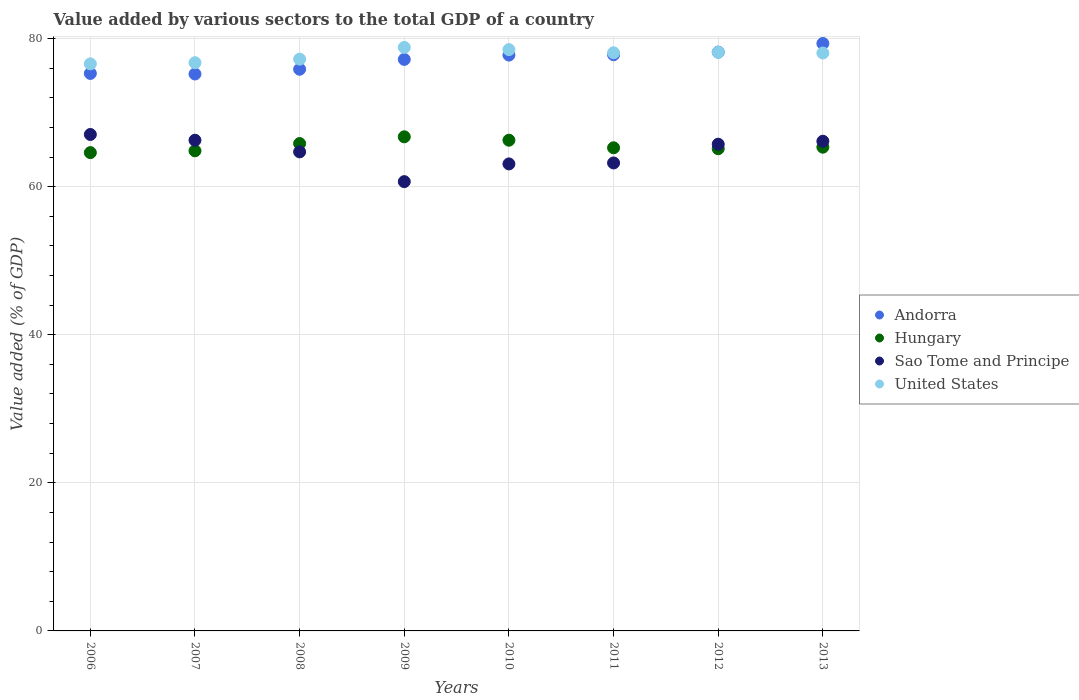How many different coloured dotlines are there?
Provide a succinct answer. 4. What is the value added by various sectors to the total GDP in Sao Tome and Principe in 2010?
Provide a short and direct response. 63.07. Across all years, what is the maximum value added by various sectors to the total GDP in Hungary?
Offer a very short reply. 66.73. Across all years, what is the minimum value added by various sectors to the total GDP in United States?
Make the answer very short. 76.58. In which year was the value added by various sectors to the total GDP in Sao Tome and Principe maximum?
Offer a terse response. 2006. What is the total value added by various sectors to the total GDP in Sao Tome and Principe in the graph?
Ensure brevity in your answer.  516.84. What is the difference between the value added by various sectors to the total GDP in United States in 2007 and that in 2009?
Give a very brief answer. -2.07. What is the difference between the value added by various sectors to the total GDP in Hungary in 2010 and the value added by various sectors to the total GDP in United States in 2007?
Give a very brief answer. -10.47. What is the average value added by various sectors to the total GDP in Hungary per year?
Your response must be concise. 65.5. In the year 2007, what is the difference between the value added by various sectors to the total GDP in Hungary and value added by various sectors to the total GDP in United States?
Provide a short and direct response. -11.9. In how many years, is the value added by various sectors to the total GDP in Sao Tome and Principe greater than 48 %?
Your answer should be compact. 8. What is the ratio of the value added by various sectors to the total GDP in Sao Tome and Principe in 2006 to that in 2010?
Offer a very short reply. 1.06. Is the value added by various sectors to the total GDP in Andorra in 2007 less than that in 2010?
Make the answer very short. Yes. What is the difference between the highest and the second highest value added by various sectors to the total GDP in Andorra?
Provide a succinct answer. 1.16. What is the difference between the highest and the lowest value added by various sectors to the total GDP in Sao Tome and Principe?
Offer a very short reply. 6.37. Is it the case that in every year, the sum of the value added by various sectors to the total GDP in Andorra and value added by various sectors to the total GDP in Sao Tome and Principe  is greater than the value added by various sectors to the total GDP in United States?
Ensure brevity in your answer.  Yes. Does the value added by various sectors to the total GDP in Sao Tome and Principe monotonically increase over the years?
Provide a short and direct response. No. Is the value added by various sectors to the total GDP in Hungary strictly greater than the value added by various sectors to the total GDP in Andorra over the years?
Ensure brevity in your answer.  No. Is the value added by various sectors to the total GDP in Andorra strictly less than the value added by various sectors to the total GDP in Sao Tome and Principe over the years?
Your response must be concise. No. How many dotlines are there?
Your answer should be compact. 4. How many years are there in the graph?
Your answer should be compact. 8. Are the values on the major ticks of Y-axis written in scientific E-notation?
Provide a short and direct response. No. How many legend labels are there?
Ensure brevity in your answer.  4. How are the legend labels stacked?
Keep it short and to the point. Vertical. What is the title of the graph?
Your response must be concise. Value added by various sectors to the total GDP of a country. Does "East Asia (developing only)" appear as one of the legend labels in the graph?
Give a very brief answer. No. What is the label or title of the Y-axis?
Your answer should be compact. Value added (% of GDP). What is the Value added (% of GDP) of Andorra in 2006?
Your answer should be compact. 75.29. What is the Value added (% of GDP) of Hungary in 2006?
Give a very brief answer. 64.6. What is the Value added (% of GDP) in Sao Tome and Principe in 2006?
Provide a succinct answer. 67.05. What is the Value added (% of GDP) in United States in 2006?
Ensure brevity in your answer.  76.58. What is the Value added (% of GDP) in Andorra in 2007?
Make the answer very short. 75.21. What is the Value added (% of GDP) of Hungary in 2007?
Keep it short and to the point. 64.84. What is the Value added (% of GDP) in Sao Tome and Principe in 2007?
Your answer should be compact. 66.27. What is the Value added (% of GDP) in United States in 2007?
Ensure brevity in your answer.  76.74. What is the Value added (% of GDP) in Andorra in 2008?
Make the answer very short. 75.86. What is the Value added (% of GDP) in Hungary in 2008?
Provide a succinct answer. 65.82. What is the Value added (% of GDP) of Sao Tome and Principe in 2008?
Your response must be concise. 64.7. What is the Value added (% of GDP) in United States in 2008?
Provide a succinct answer. 77.22. What is the Value added (% of GDP) of Andorra in 2009?
Make the answer very short. 77.19. What is the Value added (% of GDP) in Hungary in 2009?
Offer a terse response. 66.73. What is the Value added (% of GDP) of Sao Tome and Principe in 2009?
Provide a short and direct response. 60.68. What is the Value added (% of GDP) in United States in 2009?
Give a very brief answer. 78.81. What is the Value added (% of GDP) of Andorra in 2010?
Offer a very short reply. 77.77. What is the Value added (% of GDP) in Hungary in 2010?
Ensure brevity in your answer.  66.27. What is the Value added (% of GDP) of Sao Tome and Principe in 2010?
Offer a terse response. 63.07. What is the Value added (% of GDP) of United States in 2010?
Offer a very short reply. 78.51. What is the Value added (% of GDP) in Andorra in 2011?
Ensure brevity in your answer.  77.82. What is the Value added (% of GDP) in Hungary in 2011?
Ensure brevity in your answer.  65.25. What is the Value added (% of GDP) in Sao Tome and Principe in 2011?
Keep it short and to the point. 63.2. What is the Value added (% of GDP) in United States in 2011?
Keep it short and to the point. 78.08. What is the Value added (% of GDP) in Andorra in 2012?
Offer a very short reply. 78.17. What is the Value added (% of GDP) in Hungary in 2012?
Keep it short and to the point. 65.12. What is the Value added (% of GDP) of Sao Tome and Principe in 2012?
Ensure brevity in your answer.  65.73. What is the Value added (% of GDP) in United States in 2012?
Offer a terse response. 78.15. What is the Value added (% of GDP) of Andorra in 2013?
Offer a terse response. 79.34. What is the Value added (% of GDP) of Hungary in 2013?
Your response must be concise. 65.33. What is the Value added (% of GDP) of Sao Tome and Principe in 2013?
Keep it short and to the point. 66.13. What is the Value added (% of GDP) in United States in 2013?
Offer a terse response. 78.05. Across all years, what is the maximum Value added (% of GDP) in Andorra?
Make the answer very short. 79.34. Across all years, what is the maximum Value added (% of GDP) in Hungary?
Ensure brevity in your answer.  66.73. Across all years, what is the maximum Value added (% of GDP) of Sao Tome and Principe?
Provide a short and direct response. 67.05. Across all years, what is the maximum Value added (% of GDP) of United States?
Provide a short and direct response. 78.81. Across all years, what is the minimum Value added (% of GDP) of Andorra?
Give a very brief answer. 75.21. Across all years, what is the minimum Value added (% of GDP) of Hungary?
Offer a very short reply. 64.6. Across all years, what is the minimum Value added (% of GDP) in Sao Tome and Principe?
Offer a very short reply. 60.68. Across all years, what is the minimum Value added (% of GDP) of United States?
Offer a terse response. 76.58. What is the total Value added (% of GDP) of Andorra in the graph?
Make the answer very short. 616.65. What is the total Value added (% of GDP) in Hungary in the graph?
Ensure brevity in your answer.  523.97. What is the total Value added (% of GDP) in Sao Tome and Principe in the graph?
Keep it short and to the point. 516.84. What is the total Value added (% of GDP) in United States in the graph?
Provide a succinct answer. 622.14. What is the difference between the Value added (% of GDP) in Andorra in 2006 and that in 2007?
Provide a short and direct response. 0.08. What is the difference between the Value added (% of GDP) of Hungary in 2006 and that in 2007?
Provide a succinct answer. -0.24. What is the difference between the Value added (% of GDP) in Sao Tome and Principe in 2006 and that in 2007?
Keep it short and to the point. 0.78. What is the difference between the Value added (% of GDP) of United States in 2006 and that in 2007?
Your response must be concise. -0.16. What is the difference between the Value added (% of GDP) of Andorra in 2006 and that in 2008?
Your answer should be compact. -0.57. What is the difference between the Value added (% of GDP) in Hungary in 2006 and that in 2008?
Provide a short and direct response. -1.23. What is the difference between the Value added (% of GDP) in Sao Tome and Principe in 2006 and that in 2008?
Keep it short and to the point. 2.35. What is the difference between the Value added (% of GDP) in United States in 2006 and that in 2008?
Keep it short and to the point. -0.64. What is the difference between the Value added (% of GDP) of Andorra in 2006 and that in 2009?
Your answer should be compact. -1.9. What is the difference between the Value added (% of GDP) in Hungary in 2006 and that in 2009?
Make the answer very short. -2.14. What is the difference between the Value added (% of GDP) in Sao Tome and Principe in 2006 and that in 2009?
Your answer should be compact. 6.37. What is the difference between the Value added (% of GDP) in United States in 2006 and that in 2009?
Your response must be concise. -2.23. What is the difference between the Value added (% of GDP) in Andorra in 2006 and that in 2010?
Your response must be concise. -2.48. What is the difference between the Value added (% of GDP) in Hungary in 2006 and that in 2010?
Make the answer very short. -1.68. What is the difference between the Value added (% of GDP) of Sao Tome and Principe in 2006 and that in 2010?
Your answer should be compact. 3.98. What is the difference between the Value added (% of GDP) in United States in 2006 and that in 2010?
Your answer should be compact. -1.93. What is the difference between the Value added (% of GDP) in Andorra in 2006 and that in 2011?
Keep it short and to the point. -2.53. What is the difference between the Value added (% of GDP) in Hungary in 2006 and that in 2011?
Offer a terse response. -0.65. What is the difference between the Value added (% of GDP) of Sao Tome and Principe in 2006 and that in 2011?
Provide a short and direct response. 3.85. What is the difference between the Value added (% of GDP) in United States in 2006 and that in 2011?
Make the answer very short. -1.5. What is the difference between the Value added (% of GDP) in Andorra in 2006 and that in 2012?
Provide a succinct answer. -2.88. What is the difference between the Value added (% of GDP) in Hungary in 2006 and that in 2012?
Provide a succinct answer. -0.53. What is the difference between the Value added (% of GDP) of Sao Tome and Principe in 2006 and that in 2012?
Your answer should be very brief. 1.31. What is the difference between the Value added (% of GDP) in United States in 2006 and that in 2012?
Your answer should be very brief. -1.57. What is the difference between the Value added (% of GDP) in Andorra in 2006 and that in 2013?
Offer a very short reply. -4.05. What is the difference between the Value added (% of GDP) of Hungary in 2006 and that in 2013?
Your answer should be compact. -0.74. What is the difference between the Value added (% of GDP) of Sao Tome and Principe in 2006 and that in 2013?
Make the answer very short. 0.91. What is the difference between the Value added (% of GDP) in United States in 2006 and that in 2013?
Offer a terse response. -1.47. What is the difference between the Value added (% of GDP) in Andorra in 2007 and that in 2008?
Ensure brevity in your answer.  -0.64. What is the difference between the Value added (% of GDP) of Hungary in 2007 and that in 2008?
Your answer should be very brief. -0.98. What is the difference between the Value added (% of GDP) of Sao Tome and Principe in 2007 and that in 2008?
Provide a succinct answer. 1.57. What is the difference between the Value added (% of GDP) in United States in 2007 and that in 2008?
Ensure brevity in your answer.  -0.48. What is the difference between the Value added (% of GDP) of Andorra in 2007 and that in 2009?
Your answer should be compact. -1.97. What is the difference between the Value added (% of GDP) of Hungary in 2007 and that in 2009?
Offer a terse response. -1.89. What is the difference between the Value added (% of GDP) in Sao Tome and Principe in 2007 and that in 2009?
Offer a very short reply. 5.59. What is the difference between the Value added (% of GDP) of United States in 2007 and that in 2009?
Provide a short and direct response. -2.07. What is the difference between the Value added (% of GDP) of Andorra in 2007 and that in 2010?
Offer a terse response. -2.56. What is the difference between the Value added (% of GDP) of Hungary in 2007 and that in 2010?
Provide a short and direct response. -1.43. What is the difference between the Value added (% of GDP) in Sao Tome and Principe in 2007 and that in 2010?
Provide a succinct answer. 3.2. What is the difference between the Value added (% of GDP) in United States in 2007 and that in 2010?
Your answer should be very brief. -1.77. What is the difference between the Value added (% of GDP) in Andorra in 2007 and that in 2011?
Offer a very short reply. -2.6. What is the difference between the Value added (% of GDP) in Hungary in 2007 and that in 2011?
Your answer should be very brief. -0.41. What is the difference between the Value added (% of GDP) in Sao Tome and Principe in 2007 and that in 2011?
Your answer should be compact. 3.07. What is the difference between the Value added (% of GDP) of United States in 2007 and that in 2011?
Give a very brief answer. -1.34. What is the difference between the Value added (% of GDP) of Andorra in 2007 and that in 2012?
Offer a very short reply. -2.96. What is the difference between the Value added (% of GDP) in Hungary in 2007 and that in 2012?
Your answer should be very brief. -0.28. What is the difference between the Value added (% of GDP) in Sao Tome and Principe in 2007 and that in 2012?
Your answer should be compact. 0.54. What is the difference between the Value added (% of GDP) in United States in 2007 and that in 2012?
Offer a very short reply. -1.41. What is the difference between the Value added (% of GDP) of Andorra in 2007 and that in 2013?
Provide a succinct answer. -4.12. What is the difference between the Value added (% of GDP) of Hungary in 2007 and that in 2013?
Keep it short and to the point. -0.49. What is the difference between the Value added (% of GDP) in Sao Tome and Principe in 2007 and that in 2013?
Give a very brief answer. 0.14. What is the difference between the Value added (% of GDP) in United States in 2007 and that in 2013?
Provide a short and direct response. -1.31. What is the difference between the Value added (% of GDP) of Andorra in 2008 and that in 2009?
Ensure brevity in your answer.  -1.33. What is the difference between the Value added (% of GDP) of Hungary in 2008 and that in 2009?
Give a very brief answer. -0.91. What is the difference between the Value added (% of GDP) in Sao Tome and Principe in 2008 and that in 2009?
Provide a succinct answer. 4.02. What is the difference between the Value added (% of GDP) in United States in 2008 and that in 2009?
Provide a short and direct response. -1.59. What is the difference between the Value added (% of GDP) of Andorra in 2008 and that in 2010?
Make the answer very short. -1.91. What is the difference between the Value added (% of GDP) in Hungary in 2008 and that in 2010?
Keep it short and to the point. -0.45. What is the difference between the Value added (% of GDP) in Sao Tome and Principe in 2008 and that in 2010?
Keep it short and to the point. 1.63. What is the difference between the Value added (% of GDP) of United States in 2008 and that in 2010?
Your response must be concise. -1.28. What is the difference between the Value added (% of GDP) of Andorra in 2008 and that in 2011?
Provide a short and direct response. -1.96. What is the difference between the Value added (% of GDP) in Hungary in 2008 and that in 2011?
Ensure brevity in your answer.  0.57. What is the difference between the Value added (% of GDP) of Sao Tome and Principe in 2008 and that in 2011?
Make the answer very short. 1.5. What is the difference between the Value added (% of GDP) of United States in 2008 and that in 2011?
Give a very brief answer. -0.86. What is the difference between the Value added (% of GDP) in Andorra in 2008 and that in 2012?
Give a very brief answer. -2.32. What is the difference between the Value added (% of GDP) in Sao Tome and Principe in 2008 and that in 2012?
Offer a very short reply. -1.04. What is the difference between the Value added (% of GDP) of United States in 2008 and that in 2012?
Your answer should be compact. -0.92. What is the difference between the Value added (% of GDP) in Andorra in 2008 and that in 2013?
Offer a terse response. -3.48. What is the difference between the Value added (% of GDP) in Hungary in 2008 and that in 2013?
Keep it short and to the point. 0.49. What is the difference between the Value added (% of GDP) in Sao Tome and Principe in 2008 and that in 2013?
Provide a short and direct response. -1.44. What is the difference between the Value added (% of GDP) in United States in 2008 and that in 2013?
Your response must be concise. -0.83. What is the difference between the Value added (% of GDP) of Andorra in 2009 and that in 2010?
Make the answer very short. -0.58. What is the difference between the Value added (% of GDP) in Hungary in 2009 and that in 2010?
Provide a succinct answer. 0.46. What is the difference between the Value added (% of GDP) of Sao Tome and Principe in 2009 and that in 2010?
Your answer should be compact. -2.39. What is the difference between the Value added (% of GDP) of United States in 2009 and that in 2010?
Your answer should be very brief. 0.3. What is the difference between the Value added (% of GDP) of Andorra in 2009 and that in 2011?
Give a very brief answer. -0.63. What is the difference between the Value added (% of GDP) in Hungary in 2009 and that in 2011?
Your answer should be very brief. 1.48. What is the difference between the Value added (% of GDP) in Sao Tome and Principe in 2009 and that in 2011?
Make the answer very short. -2.52. What is the difference between the Value added (% of GDP) of United States in 2009 and that in 2011?
Give a very brief answer. 0.73. What is the difference between the Value added (% of GDP) in Andorra in 2009 and that in 2012?
Give a very brief answer. -0.99. What is the difference between the Value added (% of GDP) in Hungary in 2009 and that in 2012?
Provide a short and direct response. 1.61. What is the difference between the Value added (% of GDP) of Sao Tome and Principe in 2009 and that in 2012?
Your response must be concise. -5.06. What is the difference between the Value added (% of GDP) in United States in 2009 and that in 2012?
Provide a succinct answer. 0.66. What is the difference between the Value added (% of GDP) in Andorra in 2009 and that in 2013?
Your answer should be very brief. -2.15. What is the difference between the Value added (% of GDP) in Hungary in 2009 and that in 2013?
Your answer should be very brief. 1.4. What is the difference between the Value added (% of GDP) in Sao Tome and Principe in 2009 and that in 2013?
Offer a terse response. -5.46. What is the difference between the Value added (% of GDP) in United States in 2009 and that in 2013?
Ensure brevity in your answer.  0.76. What is the difference between the Value added (% of GDP) of Andorra in 2010 and that in 2011?
Ensure brevity in your answer.  -0.05. What is the difference between the Value added (% of GDP) of Hungary in 2010 and that in 2011?
Offer a very short reply. 1.02. What is the difference between the Value added (% of GDP) of Sao Tome and Principe in 2010 and that in 2011?
Your answer should be compact. -0.13. What is the difference between the Value added (% of GDP) in United States in 2010 and that in 2011?
Offer a terse response. 0.43. What is the difference between the Value added (% of GDP) in Andorra in 2010 and that in 2012?
Keep it short and to the point. -0.4. What is the difference between the Value added (% of GDP) in Hungary in 2010 and that in 2012?
Your answer should be very brief. 1.15. What is the difference between the Value added (% of GDP) of Sao Tome and Principe in 2010 and that in 2012?
Give a very brief answer. -2.66. What is the difference between the Value added (% of GDP) in United States in 2010 and that in 2012?
Your answer should be compact. 0.36. What is the difference between the Value added (% of GDP) in Andorra in 2010 and that in 2013?
Your response must be concise. -1.57. What is the difference between the Value added (% of GDP) of Hungary in 2010 and that in 2013?
Give a very brief answer. 0.94. What is the difference between the Value added (% of GDP) in Sao Tome and Principe in 2010 and that in 2013?
Make the answer very short. -3.06. What is the difference between the Value added (% of GDP) in United States in 2010 and that in 2013?
Give a very brief answer. 0.46. What is the difference between the Value added (% of GDP) of Andorra in 2011 and that in 2012?
Offer a terse response. -0.35. What is the difference between the Value added (% of GDP) of Hungary in 2011 and that in 2012?
Make the answer very short. 0.13. What is the difference between the Value added (% of GDP) in Sao Tome and Principe in 2011 and that in 2012?
Keep it short and to the point. -2.53. What is the difference between the Value added (% of GDP) of United States in 2011 and that in 2012?
Your response must be concise. -0.07. What is the difference between the Value added (% of GDP) of Andorra in 2011 and that in 2013?
Offer a very short reply. -1.52. What is the difference between the Value added (% of GDP) in Hungary in 2011 and that in 2013?
Provide a succinct answer. -0.08. What is the difference between the Value added (% of GDP) in Sao Tome and Principe in 2011 and that in 2013?
Offer a very short reply. -2.93. What is the difference between the Value added (% of GDP) in United States in 2011 and that in 2013?
Your answer should be compact. 0.03. What is the difference between the Value added (% of GDP) of Andorra in 2012 and that in 2013?
Ensure brevity in your answer.  -1.16. What is the difference between the Value added (% of GDP) of Hungary in 2012 and that in 2013?
Offer a terse response. -0.21. What is the difference between the Value added (% of GDP) of Sao Tome and Principe in 2012 and that in 2013?
Offer a terse response. -0.4. What is the difference between the Value added (% of GDP) of United States in 2012 and that in 2013?
Your response must be concise. 0.09. What is the difference between the Value added (% of GDP) of Andorra in 2006 and the Value added (% of GDP) of Hungary in 2007?
Your answer should be compact. 10.45. What is the difference between the Value added (% of GDP) of Andorra in 2006 and the Value added (% of GDP) of Sao Tome and Principe in 2007?
Keep it short and to the point. 9.02. What is the difference between the Value added (% of GDP) of Andorra in 2006 and the Value added (% of GDP) of United States in 2007?
Your response must be concise. -1.45. What is the difference between the Value added (% of GDP) of Hungary in 2006 and the Value added (% of GDP) of Sao Tome and Principe in 2007?
Your response must be concise. -1.67. What is the difference between the Value added (% of GDP) of Hungary in 2006 and the Value added (% of GDP) of United States in 2007?
Your answer should be compact. -12.14. What is the difference between the Value added (% of GDP) of Sao Tome and Principe in 2006 and the Value added (% of GDP) of United States in 2007?
Offer a terse response. -9.69. What is the difference between the Value added (% of GDP) of Andorra in 2006 and the Value added (% of GDP) of Hungary in 2008?
Give a very brief answer. 9.47. What is the difference between the Value added (% of GDP) in Andorra in 2006 and the Value added (% of GDP) in Sao Tome and Principe in 2008?
Make the answer very short. 10.59. What is the difference between the Value added (% of GDP) in Andorra in 2006 and the Value added (% of GDP) in United States in 2008?
Your answer should be very brief. -1.93. What is the difference between the Value added (% of GDP) of Hungary in 2006 and the Value added (% of GDP) of Sao Tome and Principe in 2008?
Offer a very short reply. -0.1. What is the difference between the Value added (% of GDP) in Hungary in 2006 and the Value added (% of GDP) in United States in 2008?
Your response must be concise. -12.63. What is the difference between the Value added (% of GDP) in Sao Tome and Principe in 2006 and the Value added (% of GDP) in United States in 2008?
Make the answer very short. -10.17. What is the difference between the Value added (% of GDP) of Andorra in 2006 and the Value added (% of GDP) of Hungary in 2009?
Your response must be concise. 8.56. What is the difference between the Value added (% of GDP) of Andorra in 2006 and the Value added (% of GDP) of Sao Tome and Principe in 2009?
Ensure brevity in your answer.  14.61. What is the difference between the Value added (% of GDP) of Andorra in 2006 and the Value added (% of GDP) of United States in 2009?
Provide a short and direct response. -3.52. What is the difference between the Value added (% of GDP) of Hungary in 2006 and the Value added (% of GDP) of Sao Tome and Principe in 2009?
Give a very brief answer. 3.92. What is the difference between the Value added (% of GDP) in Hungary in 2006 and the Value added (% of GDP) in United States in 2009?
Your response must be concise. -14.21. What is the difference between the Value added (% of GDP) of Sao Tome and Principe in 2006 and the Value added (% of GDP) of United States in 2009?
Give a very brief answer. -11.76. What is the difference between the Value added (% of GDP) in Andorra in 2006 and the Value added (% of GDP) in Hungary in 2010?
Make the answer very short. 9.02. What is the difference between the Value added (% of GDP) of Andorra in 2006 and the Value added (% of GDP) of Sao Tome and Principe in 2010?
Offer a terse response. 12.22. What is the difference between the Value added (% of GDP) in Andorra in 2006 and the Value added (% of GDP) in United States in 2010?
Ensure brevity in your answer.  -3.22. What is the difference between the Value added (% of GDP) of Hungary in 2006 and the Value added (% of GDP) of Sao Tome and Principe in 2010?
Your answer should be very brief. 1.52. What is the difference between the Value added (% of GDP) of Hungary in 2006 and the Value added (% of GDP) of United States in 2010?
Give a very brief answer. -13.91. What is the difference between the Value added (% of GDP) in Sao Tome and Principe in 2006 and the Value added (% of GDP) in United States in 2010?
Offer a terse response. -11.46. What is the difference between the Value added (% of GDP) of Andorra in 2006 and the Value added (% of GDP) of Hungary in 2011?
Offer a very short reply. 10.04. What is the difference between the Value added (% of GDP) in Andorra in 2006 and the Value added (% of GDP) in Sao Tome and Principe in 2011?
Provide a short and direct response. 12.09. What is the difference between the Value added (% of GDP) in Andorra in 2006 and the Value added (% of GDP) in United States in 2011?
Keep it short and to the point. -2.79. What is the difference between the Value added (% of GDP) in Hungary in 2006 and the Value added (% of GDP) in Sao Tome and Principe in 2011?
Make the answer very short. 1.39. What is the difference between the Value added (% of GDP) in Hungary in 2006 and the Value added (% of GDP) in United States in 2011?
Provide a succinct answer. -13.48. What is the difference between the Value added (% of GDP) in Sao Tome and Principe in 2006 and the Value added (% of GDP) in United States in 2011?
Offer a terse response. -11.03. What is the difference between the Value added (% of GDP) of Andorra in 2006 and the Value added (% of GDP) of Hungary in 2012?
Provide a short and direct response. 10.17. What is the difference between the Value added (% of GDP) in Andorra in 2006 and the Value added (% of GDP) in Sao Tome and Principe in 2012?
Provide a short and direct response. 9.56. What is the difference between the Value added (% of GDP) in Andorra in 2006 and the Value added (% of GDP) in United States in 2012?
Ensure brevity in your answer.  -2.86. What is the difference between the Value added (% of GDP) of Hungary in 2006 and the Value added (% of GDP) of Sao Tome and Principe in 2012?
Keep it short and to the point. -1.14. What is the difference between the Value added (% of GDP) of Hungary in 2006 and the Value added (% of GDP) of United States in 2012?
Ensure brevity in your answer.  -13.55. What is the difference between the Value added (% of GDP) of Sao Tome and Principe in 2006 and the Value added (% of GDP) of United States in 2012?
Give a very brief answer. -11.1. What is the difference between the Value added (% of GDP) in Andorra in 2006 and the Value added (% of GDP) in Hungary in 2013?
Your answer should be very brief. 9.96. What is the difference between the Value added (% of GDP) in Andorra in 2006 and the Value added (% of GDP) in Sao Tome and Principe in 2013?
Provide a succinct answer. 9.16. What is the difference between the Value added (% of GDP) of Andorra in 2006 and the Value added (% of GDP) of United States in 2013?
Give a very brief answer. -2.76. What is the difference between the Value added (% of GDP) in Hungary in 2006 and the Value added (% of GDP) in Sao Tome and Principe in 2013?
Offer a terse response. -1.54. What is the difference between the Value added (% of GDP) in Hungary in 2006 and the Value added (% of GDP) in United States in 2013?
Your answer should be compact. -13.46. What is the difference between the Value added (% of GDP) of Sao Tome and Principe in 2006 and the Value added (% of GDP) of United States in 2013?
Offer a very short reply. -11. What is the difference between the Value added (% of GDP) of Andorra in 2007 and the Value added (% of GDP) of Hungary in 2008?
Provide a succinct answer. 9.39. What is the difference between the Value added (% of GDP) of Andorra in 2007 and the Value added (% of GDP) of Sao Tome and Principe in 2008?
Your answer should be compact. 10.52. What is the difference between the Value added (% of GDP) of Andorra in 2007 and the Value added (% of GDP) of United States in 2008?
Give a very brief answer. -2.01. What is the difference between the Value added (% of GDP) of Hungary in 2007 and the Value added (% of GDP) of Sao Tome and Principe in 2008?
Your response must be concise. 0.14. What is the difference between the Value added (% of GDP) of Hungary in 2007 and the Value added (% of GDP) of United States in 2008?
Your answer should be very brief. -12.38. What is the difference between the Value added (% of GDP) of Sao Tome and Principe in 2007 and the Value added (% of GDP) of United States in 2008?
Provide a succinct answer. -10.95. What is the difference between the Value added (% of GDP) of Andorra in 2007 and the Value added (% of GDP) of Hungary in 2009?
Ensure brevity in your answer.  8.48. What is the difference between the Value added (% of GDP) of Andorra in 2007 and the Value added (% of GDP) of Sao Tome and Principe in 2009?
Provide a succinct answer. 14.54. What is the difference between the Value added (% of GDP) in Andorra in 2007 and the Value added (% of GDP) in United States in 2009?
Your answer should be very brief. -3.59. What is the difference between the Value added (% of GDP) in Hungary in 2007 and the Value added (% of GDP) in Sao Tome and Principe in 2009?
Make the answer very short. 4.16. What is the difference between the Value added (% of GDP) in Hungary in 2007 and the Value added (% of GDP) in United States in 2009?
Keep it short and to the point. -13.97. What is the difference between the Value added (% of GDP) of Sao Tome and Principe in 2007 and the Value added (% of GDP) of United States in 2009?
Offer a terse response. -12.54. What is the difference between the Value added (% of GDP) in Andorra in 2007 and the Value added (% of GDP) in Hungary in 2010?
Keep it short and to the point. 8.94. What is the difference between the Value added (% of GDP) of Andorra in 2007 and the Value added (% of GDP) of Sao Tome and Principe in 2010?
Your answer should be very brief. 12.14. What is the difference between the Value added (% of GDP) of Andorra in 2007 and the Value added (% of GDP) of United States in 2010?
Keep it short and to the point. -3.29. What is the difference between the Value added (% of GDP) in Hungary in 2007 and the Value added (% of GDP) in Sao Tome and Principe in 2010?
Offer a terse response. 1.77. What is the difference between the Value added (% of GDP) in Hungary in 2007 and the Value added (% of GDP) in United States in 2010?
Provide a short and direct response. -13.67. What is the difference between the Value added (% of GDP) of Sao Tome and Principe in 2007 and the Value added (% of GDP) of United States in 2010?
Your answer should be very brief. -12.24. What is the difference between the Value added (% of GDP) of Andorra in 2007 and the Value added (% of GDP) of Hungary in 2011?
Keep it short and to the point. 9.96. What is the difference between the Value added (% of GDP) of Andorra in 2007 and the Value added (% of GDP) of Sao Tome and Principe in 2011?
Offer a very short reply. 12.01. What is the difference between the Value added (% of GDP) in Andorra in 2007 and the Value added (% of GDP) in United States in 2011?
Ensure brevity in your answer.  -2.87. What is the difference between the Value added (% of GDP) in Hungary in 2007 and the Value added (% of GDP) in Sao Tome and Principe in 2011?
Your answer should be very brief. 1.64. What is the difference between the Value added (% of GDP) of Hungary in 2007 and the Value added (% of GDP) of United States in 2011?
Make the answer very short. -13.24. What is the difference between the Value added (% of GDP) of Sao Tome and Principe in 2007 and the Value added (% of GDP) of United States in 2011?
Your answer should be compact. -11.81. What is the difference between the Value added (% of GDP) of Andorra in 2007 and the Value added (% of GDP) of Hungary in 2012?
Keep it short and to the point. 10.09. What is the difference between the Value added (% of GDP) of Andorra in 2007 and the Value added (% of GDP) of Sao Tome and Principe in 2012?
Provide a short and direct response. 9.48. What is the difference between the Value added (% of GDP) of Andorra in 2007 and the Value added (% of GDP) of United States in 2012?
Ensure brevity in your answer.  -2.93. What is the difference between the Value added (% of GDP) of Hungary in 2007 and the Value added (% of GDP) of Sao Tome and Principe in 2012?
Give a very brief answer. -0.9. What is the difference between the Value added (% of GDP) of Hungary in 2007 and the Value added (% of GDP) of United States in 2012?
Provide a short and direct response. -13.31. What is the difference between the Value added (% of GDP) in Sao Tome and Principe in 2007 and the Value added (% of GDP) in United States in 2012?
Give a very brief answer. -11.88. What is the difference between the Value added (% of GDP) in Andorra in 2007 and the Value added (% of GDP) in Hungary in 2013?
Give a very brief answer. 9.88. What is the difference between the Value added (% of GDP) in Andorra in 2007 and the Value added (% of GDP) in Sao Tome and Principe in 2013?
Provide a succinct answer. 9.08. What is the difference between the Value added (% of GDP) in Andorra in 2007 and the Value added (% of GDP) in United States in 2013?
Make the answer very short. -2.84. What is the difference between the Value added (% of GDP) in Hungary in 2007 and the Value added (% of GDP) in Sao Tome and Principe in 2013?
Give a very brief answer. -1.3. What is the difference between the Value added (% of GDP) in Hungary in 2007 and the Value added (% of GDP) in United States in 2013?
Your response must be concise. -13.21. What is the difference between the Value added (% of GDP) in Sao Tome and Principe in 2007 and the Value added (% of GDP) in United States in 2013?
Ensure brevity in your answer.  -11.78. What is the difference between the Value added (% of GDP) of Andorra in 2008 and the Value added (% of GDP) of Hungary in 2009?
Ensure brevity in your answer.  9.12. What is the difference between the Value added (% of GDP) in Andorra in 2008 and the Value added (% of GDP) in Sao Tome and Principe in 2009?
Provide a short and direct response. 15.18. What is the difference between the Value added (% of GDP) in Andorra in 2008 and the Value added (% of GDP) in United States in 2009?
Offer a terse response. -2.95. What is the difference between the Value added (% of GDP) in Hungary in 2008 and the Value added (% of GDP) in Sao Tome and Principe in 2009?
Your response must be concise. 5.14. What is the difference between the Value added (% of GDP) of Hungary in 2008 and the Value added (% of GDP) of United States in 2009?
Ensure brevity in your answer.  -12.99. What is the difference between the Value added (% of GDP) in Sao Tome and Principe in 2008 and the Value added (% of GDP) in United States in 2009?
Offer a very short reply. -14.11. What is the difference between the Value added (% of GDP) in Andorra in 2008 and the Value added (% of GDP) in Hungary in 2010?
Ensure brevity in your answer.  9.58. What is the difference between the Value added (% of GDP) of Andorra in 2008 and the Value added (% of GDP) of Sao Tome and Principe in 2010?
Give a very brief answer. 12.79. What is the difference between the Value added (% of GDP) in Andorra in 2008 and the Value added (% of GDP) in United States in 2010?
Your answer should be very brief. -2.65. What is the difference between the Value added (% of GDP) of Hungary in 2008 and the Value added (% of GDP) of Sao Tome and Principe in 2010?
Keep it short and to the point. 2.75. What is the difference between the Value added (% of GDP) in Hungary in 2008 and the Value added (% of GDP) in United States in 2010?
Offer a very short reply. -12.69. What is the difference between the Value added (% of GDP) in Sao Tome and Principe in 2008 and the Value added (% of GDP) in United States in 2010?
Provide a short and direct response. -13.81. What is the difference between the Value added (% of GDP) in Andorra in 2008 and the Value added (% of GDP) in Hungary in 2011?
Provide a short and direct response. 10.61. What is the difference between the Value added (% of GDP) of Andorra in 2008 and the Value added (% of GDP) of Sao Tome and Principe in 2011?
Give a very brief answer. 12.66. What is the difference between the Value added (% of GDP) in Andorra in 2008 and the Value added (% of GDP) in United States in 2011?
Keep it short and to the point. -2.22. What is the difference between the Value added (% of GDP) in Hungary in 2008 and the Value added (% of GDP) in Sao Tome and Principe in 2011?
Offer a very short reply. 2.62. What is the difference between the Value added (% of GDP) in Hungary in 2008 and the Value added (% of GDP) in United States in 2011?
Offer a terse response. -12.26. What is the difference between the Value added (% of GDP) in Sao Tome and Principe in 2008 and the Value added (% of GDP) in United States in 2011?
Your answer should be compact. -13.38. What is the difference between the Value added (% of GDP) in Andorra in 2008 and the Value added (% of GDP) in Hungary in 2012?
Keep it short and to the point. 10.74. What is the difference between the Value added (% of GDP) of Andorra in 2008 and the Value added (% of GDP) of Sao Tome and Principe in 2012?
Ensure brevity in your answer.  10.12. What is the difference between the Value added (% of GDP) in Andorra in 2008 and the Value added (% of GDP) in United States in 2012?
Ensure brevity in your answer.  -2.29. What is the difference between the Value added (% of GDP) in Hungary in 2008 and the Value added (% of GDP) in Sao Tome and Principe in 2012?
Make the answer very short. 0.09. What is the difference between the Value added (% of GDP) in Hungary in 2008 and the Value added (% of GDP) in United States in 2012?
Provide a short and direct response. -12.32. What is the difference between the Value added (% of GDP) of Sao Tome and Principe in 2008 and the Value added (% of GDP) of United States in 2012?
Offer a very short reply. -13.45. What is the difference between the Value added (% of GDP) in Andorra in 2008 and the Value added (% of GDP) in Hungary in 2013?
Provide a short and direct response. 10.53. What is the difference between the Value added (% of GDP) in Andorra in 2008 and the Value added (% of GDP) in Sao Tome and Principe in 2013?
Your response must be concise. 9.72. What is the difference between the Value added (% of GDP) in Andorra in 2008 and the Value added (% of GDP) in United States in 2013?
Provide a short and direct response. -2.19. What is the difference between the Value added (% of GDP) in Hungary in 2008 and the Value added (% of GDP) in Sao Tome and Principe in 2013?
Offer a terse response. -0.31. What is the difference between the Value added (% of GDP) in Hungary in 2008 and the Value added (% of GDP) in United States in 2013?
Your response must be concise. -12.23. What is the difference between the Value added (% of GDP) of Sao Tome and Principe in 2008 and the Value added (% of GDP) of United States in 2013?
Offer a very short reply. -13.35. What is the difference between the Value added (% of GDP) in Andorra in 2009 and the Value added (% of GDP) in Hungary in 2010?
Your answer should be compact. 10.91. What is the difference between the Value added (% of GDP) in Andorra in 2009 and the Value added (% of GDP) in Sao Tome and Principe in 2010?
Provide a short and direct response. 14.12. What is the difference between the Value added (% of GDP) of Andorra in 2009 and the Value added (% of GDP) of United States in 2010?
Provide a short and direct response. -1.32. What is the difference between the Value added (% of GDP) in Hungary in 2009 and the Value added (% of GDP) in Sao Tome and Principe in 2010?
Your response must be concise. 3.66. What is the difference between the Value added (% of GDP) in Hungary in 2009 and the Value added (% of GDP) in United States in 2010?
Offer a very short reply. -11.77. What is the difference between the Value added (% of GDP) of Sao Tome and Principe in 2009 and the Value added (% of GDP) of United States in 2010?
Your answer should be compact. -17.83. What is the difference between the Value added (% of GDP) of Andorra in 2009 and the Value added (% of GDP) of Hungary in 2011?
Give a very brief answer. 11.94. What is the difference between the Value added (% of GDP) in Andorra in 2009 and the Value added (% of GDP) in Sao Tome and Principe in 2011?
Make the answer very short. 13.99. What is the difference between the Value added (% of GDP) in Andorra in 2009 and the Value added (% of GDP) in United States in 2011?
Your answer should be compact. -0.89. What is the difference between the Value added (% of GDP) in Hungary in 2009 and the Value added (% of GDP) in Sao Tome and Principe in 2011?
Your answer should be very brief. 3.53. What is the difference between the Value added (% of GDP) in Hungary in 2009 and the Value added (% of GDP) in United States in 2011?
Your answer should be compact. -11.35. What is the difference between the Value added (% of GDP) in Sao Tome and Principe in 2009 and the Value added (% of GDP) in United States in 2011?
Ensure brevity in your answer.  -17.4. What is the difference between the Value added (% of GDP) in Andorra in 2009 and the Value added (% of GDP) in Hungary in 2012?
Offer a terse response. 12.06. What is the difference between the Value added (% of GDP) of Andorra in 2009 and the Value added (% of GDP) of Sao Tome and Principe in 2012?
Keep it short and to the point. 11.45. What is the difference between the Value added (% of GDP) of Andorra in 2009 and the Value added (% of GDP) of United States in 2012?
Provide a succinct answer. -0.96. What is the difference between the Value added (% of GDP) in Hungary in 2009 and the Value added (% of GDP) in Sao Tome and Principe in 2012?
Provide a short and direct response. 1. What is the difference between the Value added (% of GDP) in Hungary in 2009 and the Value added (% of GDP) in United States in 2012?
Provide a short and direct response. -11.41. What is the difference between the Value added (% of GDP) in Sao Tome and Principe in 2009 and the Value added (% of GDP) in United States in 2012?
Make the answer very short. -17.47. What is the difference between the Value added (% of GDP) in Andorra in 2009 and the Value added (% of GDP) in Hungary in 2013?
Your answer should be compact. 11.85. What is the difference between the Value added (% of GDP) of Andorra in 2009 and the Value added (% of GDP) of Sao Tome and Principe in 2013?
Offer a terse response. 11.05. What is the difference between the Value added (% of GDP) of Andorra in 2009 and the Value added (% of GDP) of United States in 2013?
Provide a succinct answer. -0.87. What is the difference between the Value added (% of GDP) in Hungary in 2009 and the Value added (% of GDP) in Sao Tome and Principe in 2013?
Your answer should be compact. 0.6. What is the difference between the Value added (% of GDP) in Hungary in 2009 and the Value added (% of GDP) in United States in 2013?
Make the answer very short. -11.32. What is the difference between the Value added (% of GDP) of Sao Tome and Principe in 2009 and the Value added (% of GDP) of United States in 2013?
Keep it short and to the point. -17.37. What is the difference between the Value added (% of GDP) of Andorra in 2010 and the Value added (% of GDP) of Hungary in 2011?
Keep it short and to the point. 12.52. What is the difference between the Value added (% of GDP) of Andorra in 2010 and the Value added (% of GDP) of Sao Tome and Principe in 2011?
Provide a succinct answer. 14.57. What is the difference between the Value added (% of GDP) in Andorra in 2010 and the Value added (% of GDP) in United States in 2011?
Your response must be concise. -0.31. What is the difference between the Value added (% of GDP) of Hungary in 2010 and the Value added (% of GDP) of Sao Tome and Principe in 2011?
Your response must be concise. 3.07. What is the difference between the Value added (% of GDP) of Hungary in 2010 and the Value added (% of GDP) of United States in 2011?
Provide a short and direct response. -11.81. What is the difference between the Value added (% of GDP) of Sao Tome and Principe in 2010 and the Value added (% of GDP) of United States in 2011?
Provide a short and direct response. -15.01. What is the difference between the Value added (% of GDP) in Andorra in 2010 and the Value added (% of GDP) in Hungary in 2012?
Ensure brevity in your answer.  12.65. What is the difference between the Value added (% of GDP) in Andorra in 2010 and the Value added (% of GDP) in Sao Tome and Principe in 2012?
Keep it short and to the point. 12.04. What is the difference between the Value added (% of GDP) of Andorra in 2010 and the Value added (% of GDP) of United States in 2012?
Give a very brief answer. -0.38. What is the difference between the Value added (% of GDP) of Hungary in 2010 and the Value added (% of GDP) of Sao Tome and Principe in 2012?
Keep it short and to the point. 0.54. What is the difference between the Value added (% of GDP) of Hungary in 2010 and the Value added (% of GDP) of United States in 2012?
Ensure brevity in your answer.  -11.87. What is the difference between the Value added (% of GDP) of Sao Tome and Principe in 2010 and the Value added (% of GDP) of United States in 2012?
Offer a terse response. -15.08. What is the difference between the Value added (% of GDP) in Andorra in 2010 and the Value added (% of GDP) in Hungary in 2013?
Give a very brief answer. 12.44. What is the difference between the Value added (% of GDP) in Andorra in 2010 and the Value added (% of GDP) in Sao Tome and Principe in 2013?
Your answer should be very brief. 11.64. What is the difference between the Value added (% of GDP) in Andorra in 2010 and the Value added (% of GDP) in United States in 2013?
Give a very brief answer. -0.28. What is the difference between the Value added (% of GDP) in Hungary in 2010 and the Value added (% of GDP) in Sao Tome and Principe in 2013?
Give a very brief answer. 0.14. What is the difference between the Value added (% of GDP) in Hungary in 2010 and the Value added (% of GDP) in United States in 2013?
Give a very brief answer. -11.78. What is the difference between the Value added (% of GDP) in Sao Tome and Principe in 2010 and the Value added (% of GDP) in United States in 2013?
Make the answer very short. -14.98. What is the difference between the Value added (% of GDP) in Andorra in 2011 and the Value added (% of GDP) in Hungary in 2012?
Give a very brief answer. 12.7. What is the difference between the Value added (% of GDP) in Andorra in 2011 and the Value added (% of GDP) in Sao Tome and Principe in 2012?
Ensure brevity in your answer.  12.08. What is the difference between the Value added (% of GDP) of Andorra in 2011 and the Value added (% of GDP) of United States in 2012?
Make the answer very short. -0.33. What is the difference between the Value added (% of GDP) in Hungary in 2011 and the Value added (% of GDP) in Sao Tome and Principe in 2012?
Your answer should be very brief. -0.48. What is the difference between the Value added (% of GDP) in Hungary in 2011 and the Value added (% of GDP) in United States in 2012?
Give a very brief answer. -12.9. What is the difference between the Value added (% of GDP) in Sao Tome and Principe in 2011 and the Value added (% of GDP) in United States in 2012?
Keep it short and to the point. -14.95. What is the difference between the Value added (% of GDP) of Andorra in 2011 and the Value added (% of GDP) of Hungary in 2013?
Ensure brevity in your answer.  12.49. What is the difference between the Value added (% of GDP) of Andorra in 2011 and the Value added (% of GDP) of Sao Tome and Principe in 2013?
Your answer should be compact. 11.68. What is the difference between the Value added (% of GDP) of Andorra in 2011 and the Value added (% of GDP) of United States in 2013?
Offer a terse response. -0.23. What is the difference between the Value added (% of GDP) in Hungary in 2011 and the Value added (% of GDP) in Sao Tome and Principe in 2013?
Your answer should be very brief. -0.88. What is the difference between the Value added (% of GDP) in Hungary in 2011 and the Value added (% of GDP) in United States in 2013?
Keep it short and to the point. -12.8. What is the difference between the Value added (% of GDP) in Sao Tome and Principe in 2011 and the Value added (% of GDP) in United States in 2013?
Ensure brevity in your answer.  -14.85. What is the difference between the Value added (% of GDP) of Andorra in 2012 and the Value added (% of GDP) of Hungary in 2013?
Make the answer very short. 12.84. What is the difference between the Value added (% of GDP) in Andorra in 2012 and the Value added (% of GDP) in Sao Tome and Principe in 2013?
Your response must be concise. 12.04. What is the difference between the Value added (% of GDP) in Andorra in 2012 and the Value added (% of GDP) in United States in 2013?
Offer a terse response. 0.12. What is the difference between the Value added (% of GDP) of Hungary in 2012 and the Value added (% of GDP) of Sao Tome and Principe in 2013?
Your answer should be compact. -1.01. What is the difference between the Value added (% of GDP) in Hungary in 2012 and the Value added (% of GDP) in United States in 2013?
Offer a terse response. -12.93. What is the difference between the Value added (% of GDP) of Sao Tome and Principe in 2012 and the Value added (% of GDP) of United States in 2013?
Your answer should be very brief. -12.32. What is the average Value added (% of GDP) of Andorra per year?
Offer a very short reply. 77.08. What is the average Value added (% of GDP) of Hungary per year?
Your response must be concise. 65.5. What is the average Value added (% of GDP) in Sao Tome and Principe per year?
Your answer should be very brief. 64.6. What is the average Value added (% of GDP) of United States per year?
Keep it short and to the point. 77.77. In the year 2006, what is the difference between the Value added (% of GDP) of Andorra and Value added (% of GDP) of Hungary?
Your answer should be compact. 10.69. In the year 2006, what is the difference between the Value added (% of GDP) in Andorra and Value added (% of GDP) in Sao Tome and Principe?
Keep it short and to the point. 8.24. In the year 2006, what is the difference between the Value added (% of GDP) of Andorra and Value added (% of GDP) of United States?
Offer a very short reply. -1.29. In the year 2006, what is the difference between the Value added (% of GDP) of Hungary and Value added (% of GDP) of Sao Tome and Principe?
Ensure brevity in your answer.  -2.45. In the year 2006, what is the difference between the Value added (% of GDP) in Hungary and Value added (% of GDP) in United States?
Give a very brief answer. -11.98. In the year 2006, what is the difference between the Value added (% of GDP) of Sao Tome and Principe and Value added (% of GDP) of United States?
Provide a short and direct response. -9.53. In the year 2007, what is the difference between the Value added (% of GDP) of Andorra and Value added (% of GDP) of Hungary?
Ensure brevity in your answer.  10.37. In the year 2007, what is the difference between the Value added (% of GDP) of Andorra and Value added (% of GDP) of Sao Tome and Principe?
Offer a terse response. 8.94. In the year 2007, what is the difference between the Value added (% of GDP) in Andorra and Value added (% of GDP) in United States?
Ensure brevity in your answer.  -1.53. In the year 2007, what is the difference between the Value added (% of GDP) of Hungary and Value added (% of GDP) of Sao Tome and Principe?
Your answer should be compact. -1.43. In the year 2007, what is the difference between the Value added (% of GDP) in Hungary and Value added (% of GDP) in United States?
Offer a terse response. -11.9. In the year 2007, what is the difference between the Value added (% of GDP) of Sao Tome and Principe and Value added (% of GDP) of United States?
Your answer should be compact. -10.47. In the year 2008, what is the difference between the Value added (% of GDP) in Andorra and Value added (% of GDP) in Hungary?
Give a very brief answer. 10.04. In the year 2008, what is the difference between the Value added (% of GDP) of Andorra and Value added (% of GDP) of Sao Tome and Principe?
Offer a terse response. 11.16. In the year 2008, what is the difference between the Value added (% of GDP) in Andorra and Value added (% of GDP) in United States?
Offer a very short reply. -1.37. In the year 2008, what is the difference between the Value added (% of GDP) in Hungary and Value added (% of GDP) in Sao Tome and Principe?
Offer a very short reply. 1.12. In the year 2008, what is the difference between the Value added (% of GDP) of Hungary and Value added (% of GDP) of United States?
Offer a terse response. -11.4. In the year 2008, what is the difference between the Value added (% of GDP) of Sao Tome and Principe and Value added (% of GDP) of United States?
Provide a short and direct response. -12.52. In the year 2009, what is the difference between the Value added (% of GDP) in Andorra and Value added (% of GDP) in Hungary?
Keep it short and to the point. 10.45. In the year 2009, what is the difference between the Value added (% of GDP) of Andorra and Value added (% of GDP) of Sao Tome and Principe?
Your answer should be very brief. 16.51. In the year 2009, what is the difference between the Value added (% of GDP) of Andorra and Value added (% of GDP) of United States?
Your answer should be very brief. -1.62. In the year 2009, what is the difference between the Value added (% of GDP) of Hungary and Value added (% of GDP) of Sao Tome and Principe?
Your answer should be compact. 6.05. In the year 2009, what is the difference between the Value added (% of GDP) of Hungary and Value added (% of GDP) of United States?
Your answer should be very brief. -12.08. In the year 2009, what is the difference between the Value added (% of GDP) in Sao Tome and Principe and Value added (% of GDP) in United States?
Ensure brevity in your answer.  -18.13. In the year 2010, what is the difference between the Value added (% of GDP) of Andorra and Value added (% of GDP) of Hungary?
Your answer should be very brief. 11.5. In the year 2010, what is the difference between the Value added (% of GDP) in Andorra and Value added (% of GDP) in Sao Tome and Principe?
Ensure brevity in your answer.  14.7. In the year 2010, what is the difference between the Value added (% of GDP) in Andorra and Value added (% of GDP) in United States?
Provide a succinct answer. -0.74. In the year 2010, what is the difference between the Value added (% of GDP) in Hungary and Value added (% of GDP) in Sao Tome and Principe?
Ensure brevity in your answer.  3.2. In the year 2010, what is the difference between the Value added (% of GDP) of Hungary and Value added (% of GDP) of United States?
Keep it short and to the point. -12.23. In the year 2010, what is the difference between the Value added (% of GDP) of Sao Tome and Principe and Value added (% of GDP) of United States?
Ensure brevity in your answer.  -15.44. In the year 2011, what is the difference between the Value added (% of GDP) of Andorra and Value added (% of GDP) of Hungary?
Make the answer very short. 12.57. In the year 2011, what is the difference between the Value added (% of GDP) of Andorra and Value added (% of GDP) of Sao Tome and Principe?
Offer a very short reply. 14.62. In the year 2011, what is the difference between the Value added (% of GDP) of Andorra and Value added (% of GDP) of United States?
Ensure brevity in your answer.  -0.26. In the year 2011, what is the difference between the Value added (% of GDP) of Hungary and Value added (% of GDP) of Sao Tome and Principe?
Ensure brevity in your answer.  2.05. In the year 2011, what is the difference between the Value added (% of GDP) of Hungary and Value added (% of GDP) of United States?
Your response must be concise. -12.83. In the year 2011, what is the difference between the Value added (% of GDP) of Sao Tome and Principe and Value added (% of GDP) of United States?
Offer a terse response. -14.88. In the year 2012, what is the difference between the Value added (% of GDP) of Andorra and Value added (% of GDP) of Hungary?
Provide a short and direct response. 13.05. In the year 2012, what is the difference between the Value added (% of GDP) in Andorra and Value added (% of GDP) in Sao Tome and Principe?
Provide a short and direct response. 12.44. In the year 2012, what is the difference between the Value added (% of GDP) of Andorra and Value added (% of GDP) of United States?
Your response must be concise. 0.03. In the year 2012, what is the difference between the Value added (% of GDP) in Hungary and Value added (% of GDP) in Sao Tome and Principe?
Give a very brief answer. -0.61. In the year 2012, what is the difference between the Value added (% of GDP) in Hungary and Value added (% of GDP) in United States?
Your response must be concise. -13.03. In the year 2012, what is the difference between the Value added (% of GDP) in Sao Tome and Principe and Value added (% of GDP) in United States?
Offer a very short reply. -12.41. In the year 2013, what is the difference between the Value added (% of GDP) in Andorra and Value added (% of GDP) in Hungary?
Offer a terse response. 14. In the year 2013, what is the difference between the Value added (% of GDP) of Andorra and Value added (% of GDP) of Sao Tome and Principe?
Your answer should be compact. 13.2. In the year 2013, what is the difference between the Value added (% of GDP) of Andorra and Value added (% of GDP) of United States?
Your response must be concise. 1.28. In the year 2013, what is the difference between the Value added (% of GDP) in Hungary and Value added (% of GDP) in Sao Tome and Principe?
Keep it short and to the point. -0.8. In the year 2013, what is the difference between the Value added (% of GDP) in Hungary and Value added (% of GDP) in United States?
Your answer should be very brief. -12.72. In the year 2013, what is the difference between the Value added (% of GDP) of Sao Tome and Principe and Value added (% of GDP) of United States?
Ensure brevity in your answer.  -11.92. What is the ratio of the Value added (% of GDP) in Andorra in 2006 to that in 2007?
Your answer should be very brief. 1. What is the ratio of the Value added (% of GDP) of Sao Tome and Principe in 2006 to that in 2007?
Make the answer very short. 1.01. What is the ratio of the Value added (% of GDP) in Andorra in 2006 to that in 2008?
Your response must be concise. 0.99. What is the ratio of the Value added (% of GDP) of Hungary in 2006 to that in 2008?
Keep it short and to the point. 0.98. What is the ratio of the Value added (% of GDP) of Sao Tome and Principe in 2006 to that in 2008?
Keep it short and to the point. 1.04. What is the ratio of the Value added (% of GDP) of Andorra in 2006 to that in 2009?
Offer a very short reply. 0.98. What is the ratio of the Value added (% of GDP) in Sao Tome and Principe in 2006 to that in 2009?
Your answer should be very brief. 1.1. What is the ratio of the Value added (% of GDP) of United States in 2006 to that in 2009?
Ensure brevity in your answer.  0.97. What is the ratio of the Value added (% of GDP) in Andorra in 2006 to that in 2010?
Offer a very short reply. 0.97. What is the ratio of the Value added (% of GDP) in Hungary in 2006 to that in 2010?
Provide a short and direct response. 0.97. What is the ratio of the Value added (% of GDP) of Sao Tome and Principe in 2006 to that in 2010?
Offer a very short reply. 1.06. What is the ratio of the Value added (% of GDP) in United States in 2006 to that in 2010?
Keep it short and to the point. 0.98. What is the ratio of the Value added (% of GDP) of Andorra in 2006 to that in 2011?
Your response must be concise. 0.97. What is the ratio of the Value added (% of GDP) in Hungary in 2006 to that in 2011?
Your response must be concise. 0.99. What is the ratio of the Value added (% of GDP) of Sao Tome and Principe in 2006 to that in 2011?
Offer a very short reply. 1.06. What is the ratio of the Value added (% of GDP) in United States in 2006 to that in 2011?
Your answer should be compact. 0.98. What is the ratio of the Value added (% of GDP) in Andorra in 2006 to that in 2012?
Offer a very short reply. 0.96. What is the ratio of the Value added (% of GDP) of Sao Tome and Principe in 2006 to that in 2012?
Keep it short and to the point. 1.02. What is the ratio of the Value added (% of GDP) in Andorra in 2006 to that in 2013?
Provide a short and direct response. 0.95. What is the ratio of the Value added (% of GDP) in Hungary in 2006 to that in 2013?
Ensure brevity in your answer.  0.99. What is the ratio of the Value added (% of GDP) of Sao Tome and Principe in 2006 to that in 2013?
Your answer should be very brief. 1.01. What is the ratio of the Value added (% of GDP) in United States in 2006 to that in 2013?
Offer a terse response. 0.98. What is the ratio of the Value added (% of GDP) of Hungary in 2007 to that in 2008?
Your answer should be very brief. 0.99. What is the ratio of the Value added (% of GDP) of Sao Tome and Principe in 2007 to that in 2008?
Keep it short and to the point. 1.02. What is the ratio of the Value added (% of GDP) of United States in 2007 to that in 2008?
Ensure brevity in your answer.  0.99. What is the ratio of the Value added (% of GDP) of Andorra in 2007 to that in 2009?
Provide a succinct answer. 0.97. What is the ratio of the Value added (% of GDP) in Hungary in 2007 to that in 2009?
Ensure brevity in your answer.  0.97. What is the ratio of the Value added (% of GDP) in Sao Tome and Principe in 2007 to that in 2009?
Provide a short and direct response. 1.09. What is the ratio of the Value added (% of GDP) of United States in 2007 to that in 2009?
Provide a succinct answer. 0.97. What is the ratio of the Value added (% of GDP) in Andorra in 2007 to that in 2010?
Your answer should be very brief. 0.97. What is the ratio of the Value added (% of GDP) in Hungary in 2007 to that in 2010?
Offer a terse response. 0.98. What is the ratio of the Value added (% of GDP) in Sao Tome and Principe in 2007 to that in 2010?
Your response must be concise. 1.05. What is the ratio of the Value added (% of GDP) of United States in 2007 to that in 2010?
Keep it short and to the point. 0.98. What is the ratio of the Value added (% of GDP) in Andorra in 2007 to that in 2011?
Give a very brief answer. 0.97. What is the ratio of the Value added (% of GDP) in Hungary in 2007 to that in 2011?
Offer a very short reply. 0.99. What is the ratio of the Value added (% of GDP) in Sao Tome and Principe in 2007 to that in 2011?
Your response must be concise. 1.05. What is the ratio of the Value added (% of GDP) in United States in 2007 to that in 2011?
Ensure brevity in your answer.  0.98. What is the ratio of the Value added (% of GDP) of Andorra in 2007 to that in 2012?
Offer a terse response. 0.96. What is the ratio of the Value added (% of GDP) of Hungary in 2007 to that in 2012?
Provide a short and direct response. 1. What is the ratio of the Value added (% of GDP) in Sao Tome and Principe in 2007 to that in 2012?
Ensure brevity in your answer.  1.01. What is the ratio of the Value added (% of GDP) in United States in 2007 to that in 2012?
Your answer should be compact. 0.98. What is the ratio of the Value added (% of GDP) in Andorra in 2007 to that in 2013?
Ensure brevity in your answer.  0.95. What is the ratio of the Value added (% of GDP) in Sao Tome and Principe in 2007 to that in 2013?
Your answer should be very brief. 1. What is the ratio of the Value added (% of GDP) in United States in 2007 to that in 2013?
Make the answer very short. 0.98. What is the ratio of the Value added (% of GDP) of Andorra in 2008 to that in 2009?
Provide a short and direct response. 0.98. What is the ratio of the Value added (% of GDP) in Hungary in 2008 to that in 2009?
Give a very brief answer. 0.99. What is the ratio of the Value added (% of GDP) of Sao Tome and Principe in 2008 to that in 2009?
Offer a very short reply. 1.07. What is the ratio of the Value added (% of GDP) in United States in 2008 to that in 2009?
Your answer should be very brief. 0.98. What is the ratio of the Value added (% of GDP) in Andorra in 2008 to that in 2010?
Offer a terse response. 0.98. What is the ratio of the Value added (% of GDP) in Sao Tome and Principe in 2008 to that in 2010?
Make the answer very short. 1.03. What is the ratio of the Value added (% of GDP) of United States in 2008 to that in 2010?
Your answer should be compact. 0.98. What is the ratio of the Value added (% of GDP) in Andorra in 2008 to that in 2011?
Give a very brief answer. 0.97. What is the ratio of the Value added (% of GDP) in Hungary in 2008 to that in 2011?
Your answer should be compact. 1.01. What is the ratio of the Value added (% of GDP) in Sao Tome and Principe in 2008 to that in 2011?
Offer a terse response. 1.02. What is the ratio of the Value added (% of GDP) in Andorra in 2008 to that in 2012?
Offer a very short reply. 0.97. What is the ratio of the Value added (% of GDP) in Hungary in 2008 to that in 2012?
Your answer should be very brief. 1.01. What is the ratio of the Value added (% of GDP) of Sao Tome and Principe in 2008 to that in 2012?
Give a very brief answer. 0.98. What is the ratio of the Value added (% of GDP) in United States in 2008 to that in 2012?
Provide a succinct answer. 0.99. What is the ratio of the Value added (% of GDP) of Andorra in 2008 to that in 2013?
Ensure brevity in your answer.  0.96. What is the ratio of the Value added (% of GDP) of Hungary in 2008 to that in 2013?
Your response must be concise. 1.01. What is the ratio of the Value added (% of GDP) of Sao Tome and Principe in 2008 to that in 2013?
Offer a very short reply. 0.98. What is the ratio of the Value added (% of GDP) in Andorra in 2009 to that in 2010?
Keep it short and to the point. 0.99. What is the ratio of the Value added (% of GDP) in Sao Tome and Principe in 2009 to that in 2010?
Give a very brief answer. 0.96. What is the ratio of the Value added (% of GDP) in Hungary in 2009 to that in 2011?
Your response must be concise. 1.02. What is the ratio of the Value added (% of GDP) in Sao Tome and Principe in 2009 to that in 2011?
Offer a terse response. 0.96. What is the ratio of the Value added (% of GDP) of United States in 2009 to that in 2011?
Your answer should be very brief. 1.01. What is the ratio of the Value added (% of GDP) of Andorra in 2009 to that in 2012?
Make the answer very short. 0.99. What is the ratio of the Value added (% of GDP) of Hungary in 2009 to that in 2012?
Your answer should be compact. 1.02. What is the ratio of the Value added (% of GDP) of United States in 2009 to that in 2012?
Keep it short and to the point. 1.01. What is the ratio of the Value added (% of GDP) of Andorra in 2009 to that in 2013?
Provide a short and direct response. 0.97. What is the ratio of the Value added (% of GDP) in Hungary in 2009 to that in 2013?
Your response must be concise. 1.02. What is the ratio of the Value added (% of GDP) in Sao Tome and Principe in 2009 to that in 2013?
Give a very brief answer. 0.92. What is the ratio of the Value added (% of GDP) of United States in 2009 to that in 2013?
Make the answer very short. 1.01. What is the ratio of the Value added (% of GDP) of Andorra in 2010 to that in 2011?
Your answer should be compact. 1. What is the ratio of the Value added (% of GDP) in Hungary in 2010 to that in 2011?
Your response must be concise. 1.02. What is the ratio of the Value added (% of GDP) of United States in 2010 to that in 2011?
Ensure brevity in your answer.  1.01. What is the ratio of the Value added (% of GDP) of Andorra in 2010 to that in 2012?
Provide a succinct answer. 0.99. What is the ratio of the Value added (% of GDP) of Hungary in 2010 to that in 2012?
Make the answer very short. 1.02. What is the ratio of the Value added (% of GDP) of Sao Tome and Principe in 2010 to that in 2012?
Offer a very short reply. 0.96. What is the ratio of the Value added (% of GDP) of Andorra in 2010 to that in 2013?
Provide a succinct answer. 0.98. What is the ratio of the Value added (% of GDP) of Hungary in 2010 to that in 2013?
Ensure brevity in your answer.  1.01. What is the ratio of the Value added (% of GDP) in Sao Tome and Principe in 2010 to that in 2013?
Ensure brevity in your answer.  0.95. What is the ratio of the Value added (% of GDP) of United States in 2010 to that in 2013?
Your answer should be very brief. 1.01. What is the ratio of the Value added (% of GDP) in Hungary in 2011 to that in 2012?
Your answer should be compact. 1. What is the ratio of the Value added (% of GDP) in Sao Tome and Principe in 2011 to that in 2012?
Make the answer very short. 0.96. What is the ratio of the Value added (% of GDP) of United States in 2011 to that in 2012?
Give a very brief answer. 1. What is the ratio of the Value added (% of GDP) in Andorra in 2011 to that in 2013?
Your answer should be compact. 0.98. What is the ratio of the Value added (% of GDP) in Sao Tome and Principe in 2011 to that in 2013?
Make the answer very short. 0.96. What is the ratio of the Value added (% of GDP) in United States in 2011 to that in 2013?
Your response must be concise. 1. What is the ratio of the Value added (% of GDP) of Hungary in 2012 to that in 2013?
Ensure brevity in your answer.  1. What is the ratio of the Value added (% of GDP) in United States in 2012 to that in 2013?
Provide a succinct answer. 1. What is the difference between the highest and the second highest Value added (% of GDP) of Andorra?
Provide a succinct answer. 1.16. What is the difference between the highest and the second highest Value added (% of GDP) in Hungary?
Your answer should be very brief. 0.46. What is the difference between the highest and the second highest Value added (% of GDP) in Sao Tome and Principe?
Offer a terse response. 0.78. What is the difference between the highest and the second highest Value added (% of GDP) of United States?
Give a very brief answer. 0.3. What is the difference between the highest and the lowest Value added (% of GDP) in Andorra?
Provide a short and direct response. 4.12. What is the difference between the highest and the lowest Value added (% of GDP) of Hungary?
Offer a terse response. 2.14. What is the difference between the highest and the lowest Value added (% of GDP) in Sao Tome and Principe?
Make the answer very short. 6.37. What is the difference between the highest and the lowest Value added (% of GDP) in United States?
Your response must be concise. 2.23. 